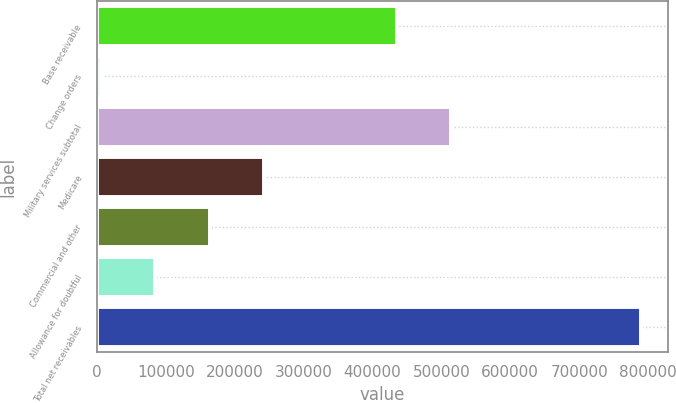Convert chart to OTSL. <chart><loc_0><loc_0><loc_500><loc_500><bar_chart><fcel>Base receivable<fcel>Change orders<fcel>Military services subtotal<fcel>Medicare<fcel>Commercial and other<fcel>Allowance for doubtful<fcel>Total net receivables<nl><fcel>436009<fcel>6190<fcel>514358<fcel>242384<fcel>164035<fcel>84539.2<fcel>789682<nl></chart> 